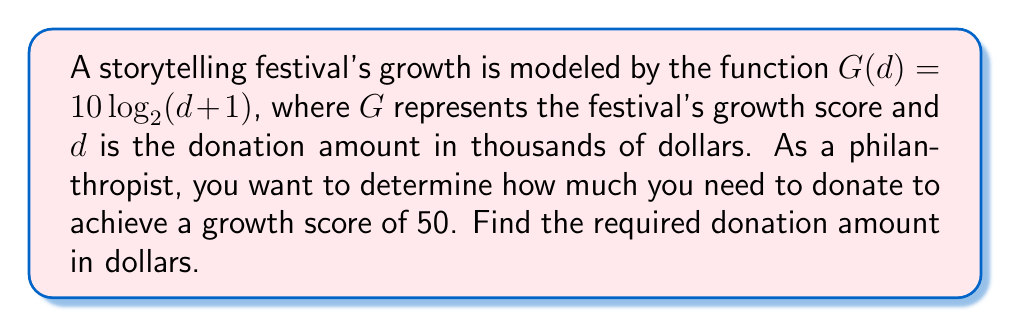Give your solution to this math problem. 1) We start with the given function: $G(d) = 10\log_2(d+1)$

2) We want to find $d$ when $G(d) = 50$. So, let's set up the equation:
   
   $50 = 10\log_2(d+1)$

3) Divide both sides by 10:
   
   $5 = \log_2(d+1)$

4) To solve for $d$, we need to apply the inverse function of $\log_2$, which is $2^x$:
   
   $2^5 = d+1$

5) Calculate $2^5$:
   
   $32 = d+1$

6) Subtract 1 from both sides:
   
   $31 = d$

7) Remember, $d$ was in thousands of dollars. To get the actual dollar amount, multiply by 1000:
   
   $31,000 = \text{donation amount in dollars}$
Answer: $31,000 